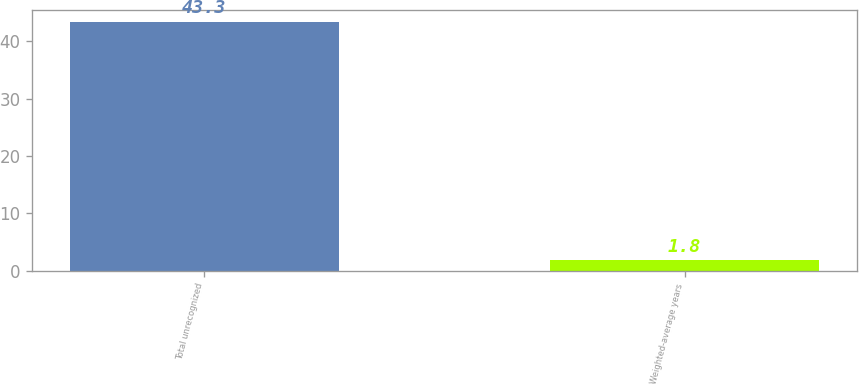Convert chart to OTSL. <chart><loc_0><loc_0><loc_500><loc_500><bar_chart><fcel>Total unrecognized<fcel>Weighted-average years<nl><fcel>43.3<fcel>1.8<nl></chart> 